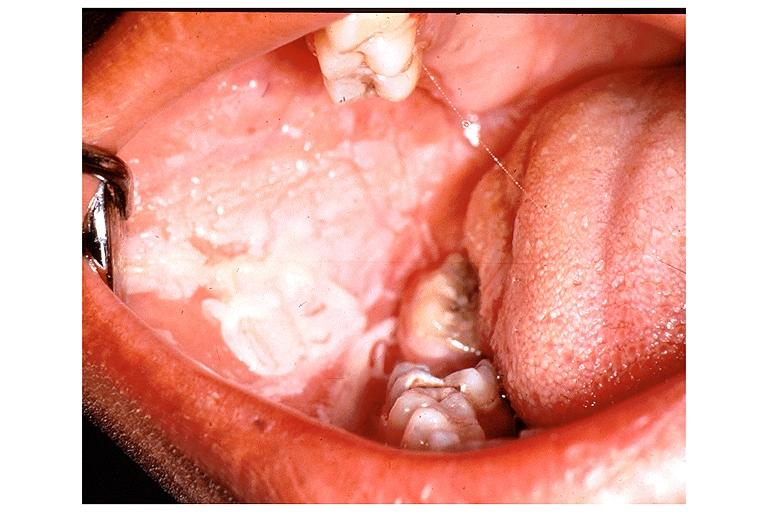do chemical burn from topical asprin?
Answer the question using a single word or phrase. Yes 